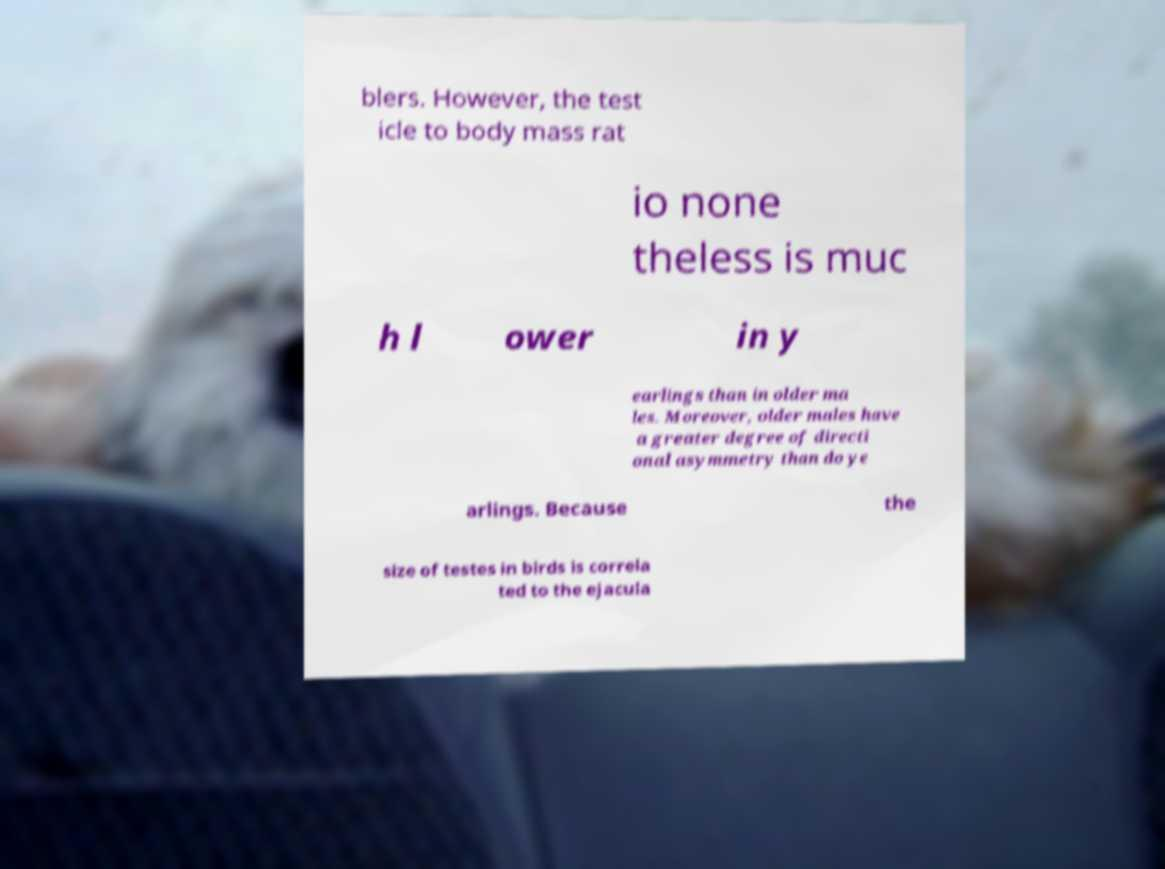There's text embedded in this image that I need extracted. Can you transcribe it verbatim? blers. However, the test icle to body mass rat io none theless is muc h l ower in y earlings than in older ma les. Moreover, older males have a greater degree of directi onal asymmetry than do ye arlings. Because the size of testes in birds is correla ted to the ejacula 